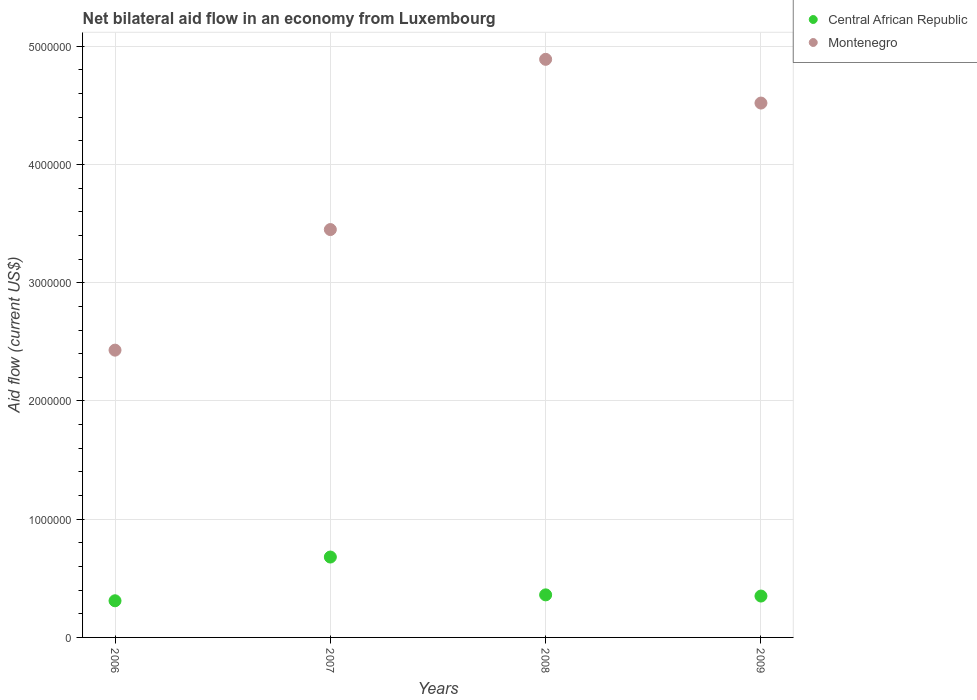How many different coloured dotlines are there?
Your answer should be compact. 2. Across all years, what is the maximum net bilateral aid flow in Central African Republic?
Offer a very short reply. 6.80e+05. Across all years, what is the minimum net bilateral aid flow in Montenegro?
Offer a very short reply. 2.43e+06. In which year was the net bilateral aid flow in Montenegro maximum?
Your answer should be compact. 2008. What is the total net bilateral aid flow in Montenegro in the graph?
Give a very brief answer. 1.53e+07. What is the difference between the net bilateral aid flow in Montenegro in 2007 and that in 2009?
Provide a succinct answer. -1.07e+06. What is the difference between the net bilateral aid flow in Montenegro in 2006 and the net bilateral aid flow in Central African Republic in 2009?
Keep it short and to the point. 2.08e+06. What is the average net bilateral aid flow in Montenegro per year?
Offer a very short reply. 3.82e+06. In the year 2009, what is the difference between the net bilateral aid flow in Central African Republic and net bilateral aid flow in Montenegro?
Offer a very short reply. -4.17e+06. In how many years, is the net bilateral aid flow in Central African Republic greater than 2200000 US$?
Offer a very short reply. 0. What is the ratio of the net bilateral aid flow in Montenegro in 2008 to that in 2009?
Provide a succinct answer. 1.08. Is the difference between the net bilateral aid flow in Central African Republic in 2007 and 2009 greater than the difference between the net bilateral aid flow in Montenegro in 2007 and 2009?
Offer a very short reply. Yes. What is the difference between the highest and the second highest net bilateral aid flow in Central African Republic?
Offer a very short reply. 3.20e+05. What is the difference between the highest and the lowest net bilateral aid flow in Montenegro?
Provide a succinct answer. 2.46e+06. Does the net bilateral aid flow in Montenegro monotonically increase over the years?
Your answer should be compact. No. Is the net bilateral aid flow in Central African Republic strictly less than the net bilateral aid flow in Montenegro over the years?
Provide a short and direct response. Yes. How many dotlines are there?
Ensure brevity in your answer.  2. Does the graph contain grids?
Keep it short and to the point. Yes. Where does the legend appear in the graph?
Ensure brevity in your answer.  Top right. How are the legend labels stacked?
Offer a very short reply. Vertical. What is the title of the graph?
Your answer should be very brief. Net bilateral aid flow in an economy from Luxembourg. What is the label or title of the X-axis?
Your response must be concise. Years. What is the label or title of the Y-axis?
Provide a succinct answer. Aid flow (current US$). What is the Aid flow (current US$) of Montenegro in 2006?
Make the answer very short. 2.43e+06. What is the Aid flow (current US$) of Central African Republic in 2007?
Offer a terse response. 6.80e+05. What is the Aid flow (current US$) of Montenegro in 2007?
Your answer should be compact. 3.45e+06. What is the Aid flow (current US$) of Central African Republic in 2008?
Ensure brevity in your answer.  3.60e+05. What is the Aid flow (current US$) in Montenegro in 2008?
Offer a very short reply. 4.89e+06. What is the Aid flow (current US$) in Montenegro in 2009?
Make the answer very short. 4.52e+06. Across all years, what is the maximum Aid flow (current US$) in Central African Republic?
Provide a short and direct response. 6.80e+05. Across all years, what is the maximum Aid flow (current US$) in Montenegro?
Offer a very short reply. 4.89e+06. Across all years, what is the minimum Aid flow (current US$) in Montenegro?
Provide a short and direct response. 2.43e+06. What is the total Aid flow (current US$) in Central African Republic in the graph?
Offer a terse response. 1.70e+06. What is the total Aid flow (current US$) of Montenegro in the graph?
Keep it short and to the point. 1.53e+07. What is the difference between the Aid flow (current US$) of Central African Republic in 2006 and that in 2007?
Provide a succinct answer. -3.70e+05. What is the difference between the Aid flow (current US$) of Montenegro in 2006 and that in 2007?
Offer a terse response. -1.02e+06. What is the difference between the Aid flow (current US$) in Central African Republic in 2006 and that in 2008?
Offer a terse response. -5.00e+04. What is the difference between the Aid flow (current US$) in Montenegro in 2006 and that in 2008?
Your answer should be very brief. -2.46e+06. What is the difference between the Aid flow (current US$) of Central African Republic in 2006 and that in 2009?
Your response must be concise. -4.00e+04. What is the difference between the Aid flow (current US$) in Montenegro in 2006 and that in 2009?
Your answer should be compact. -2.09e+06. What is the difference between the Aid flow (current US$) in Central African Republic in 2007 and that in 2008?
Offer a very short reply. 3.20e+05. What is the difference between the Aid flow (current US$) in Montenegro in 2007 and that in 2008?
Your answer should be very brief. -1.44e+06. What is the difference between the Aid flow (current US$) of Montenegro in 2007 and that in 2009?
Make the answer very short. -1.07e+06. What is the difference between the Aid flow (current US$) in Montenegro in 2008 and that in 2009?
Make the answer very short. 3.70e+05. What is the difference between the Aid flow (current US$) of Central African Republic in 2006 and the Aid flow (current US$) of Montenegro in 2007?
Offer a terse response. -3.14e+06. What is the difference between the Aid flow (current US$) in Central African Republic in 2006 and the Aid flow (current US$) in Montenegro in 2008?
Offer a very short reply. -4.58e+06. What is the difference between the Aid flow (current US$) of Central African Republic in 2006 and the Aid flow (current US$) of Montenegro in 2009?
Your answer should be very brief. -4.21e+06. What is the difference between the Aid flow (current US$) in Central African Republic in 2007 and the Aid flow (current US$) in Montenegro in 2008?
Provide a succinct answer. -4.21e+06. What is the difference between the Aid flow (current US$) in Central African Republic in 2007 and the Aid flow (current US$) in Montenegro in 2009?
Give a very brief answer. -3.84e+06. What is the difference between the Aid flow (current US$) in Central African Republic in 2008 and the Aid flow (current US$) in Montenegro in 2009?
Your answer should be very brief. -4.16e+06. What is the average Aid flow (current US$) of Central African Republic per year?
Provide a succinct answer. 4.25e+05. What is the average Aid flow (current US$) in Montenegro per year?
Offer a very short reply. 3.82e+06. In the year 2006, what is the difference between the Aid flow (current US$) in Central African Republic and Aid flow (current US$) in Montenegro?
Offer a very short reply. -2.12e+06. In the year 2007, what is the difference between the Aid flow (current US$) in Central African Republic and Aid flow (current US$) in Montenegro?
Your answer should be compact. -2.77e+06. In the year 2008, what is the difference between the Aid flow (current US$) of Central African Republic and Aid flow (current US$) of Montenegro?
Your answer should be very brief. -4.53e+06. In the year 2009, what is the difference between the Aid flow (current US$) of Central African Republic and Aid flow (current US$) of Montenegro?
Give a very brief answer. -4.17e+06. What is the ratio of the Aid flow (current US$) in Central African Republic in 2006 to that in 2007?
Provide a short and direct response. 0.46. What is the ratio of the Aid flow (current US$) of Montenegro in 2006 to that in 2007?
Your answer should be very brief. 0.7. What is the ratio of the Aid flow (current US$) of Central African Republic in 2006 to that in 2008?
Your answer should be very brief. 0.86. What is the ratio of the Aid flow (current US$) in Montenegro in 2006 to that in 2008?
Make the answer very short. 0.5. What is the ratio of the Aid flow (current US$) of Central African Republic in 2006 to that in 2009?
Provide a succinct answer. 0.89. What is the ratio of the Aid flow (current US$) of Montenegro in 2006 to that in 2009?
Ensure brevity in your answer.  0.54. What is the ratio of the Aid flow (current US$) in Central African Republic in 2007 to that in 2008?
Offer a terse response. 1.89. What is the ratio of the Aid flow (current US$) in Montenegro in 2007 to that in 2008?
Make the answer very short. 0.71. What is the ratio of the Aid flow (current US$) of Central African Republic in 2007 to that in 2009?
Your answer should be very brief. 1.94. What is the ratio of the Aid flow (current US$) of Montenegro in 2007 to that in 2009?
Your response must be concise. 0.76. What is the ratio of the Aid flow (current US$) in Central African Republic in 2008 to that in 2009?
Provide a succinct answer. 1.03. What is the ratio of the Aid flow (current US$) in Montenegro in 2008 to that in 2009?
Make the answer very short. 1.08. What is the difference between the highest and the lowest Aid flow (current US$) of Central African Republic?
Your response must be concise. 3.70e+05. What is the difference between the highest and the lowest Aid flow (current US$) of Montenegro?
Give a very brief answer. 2.46e+06. 